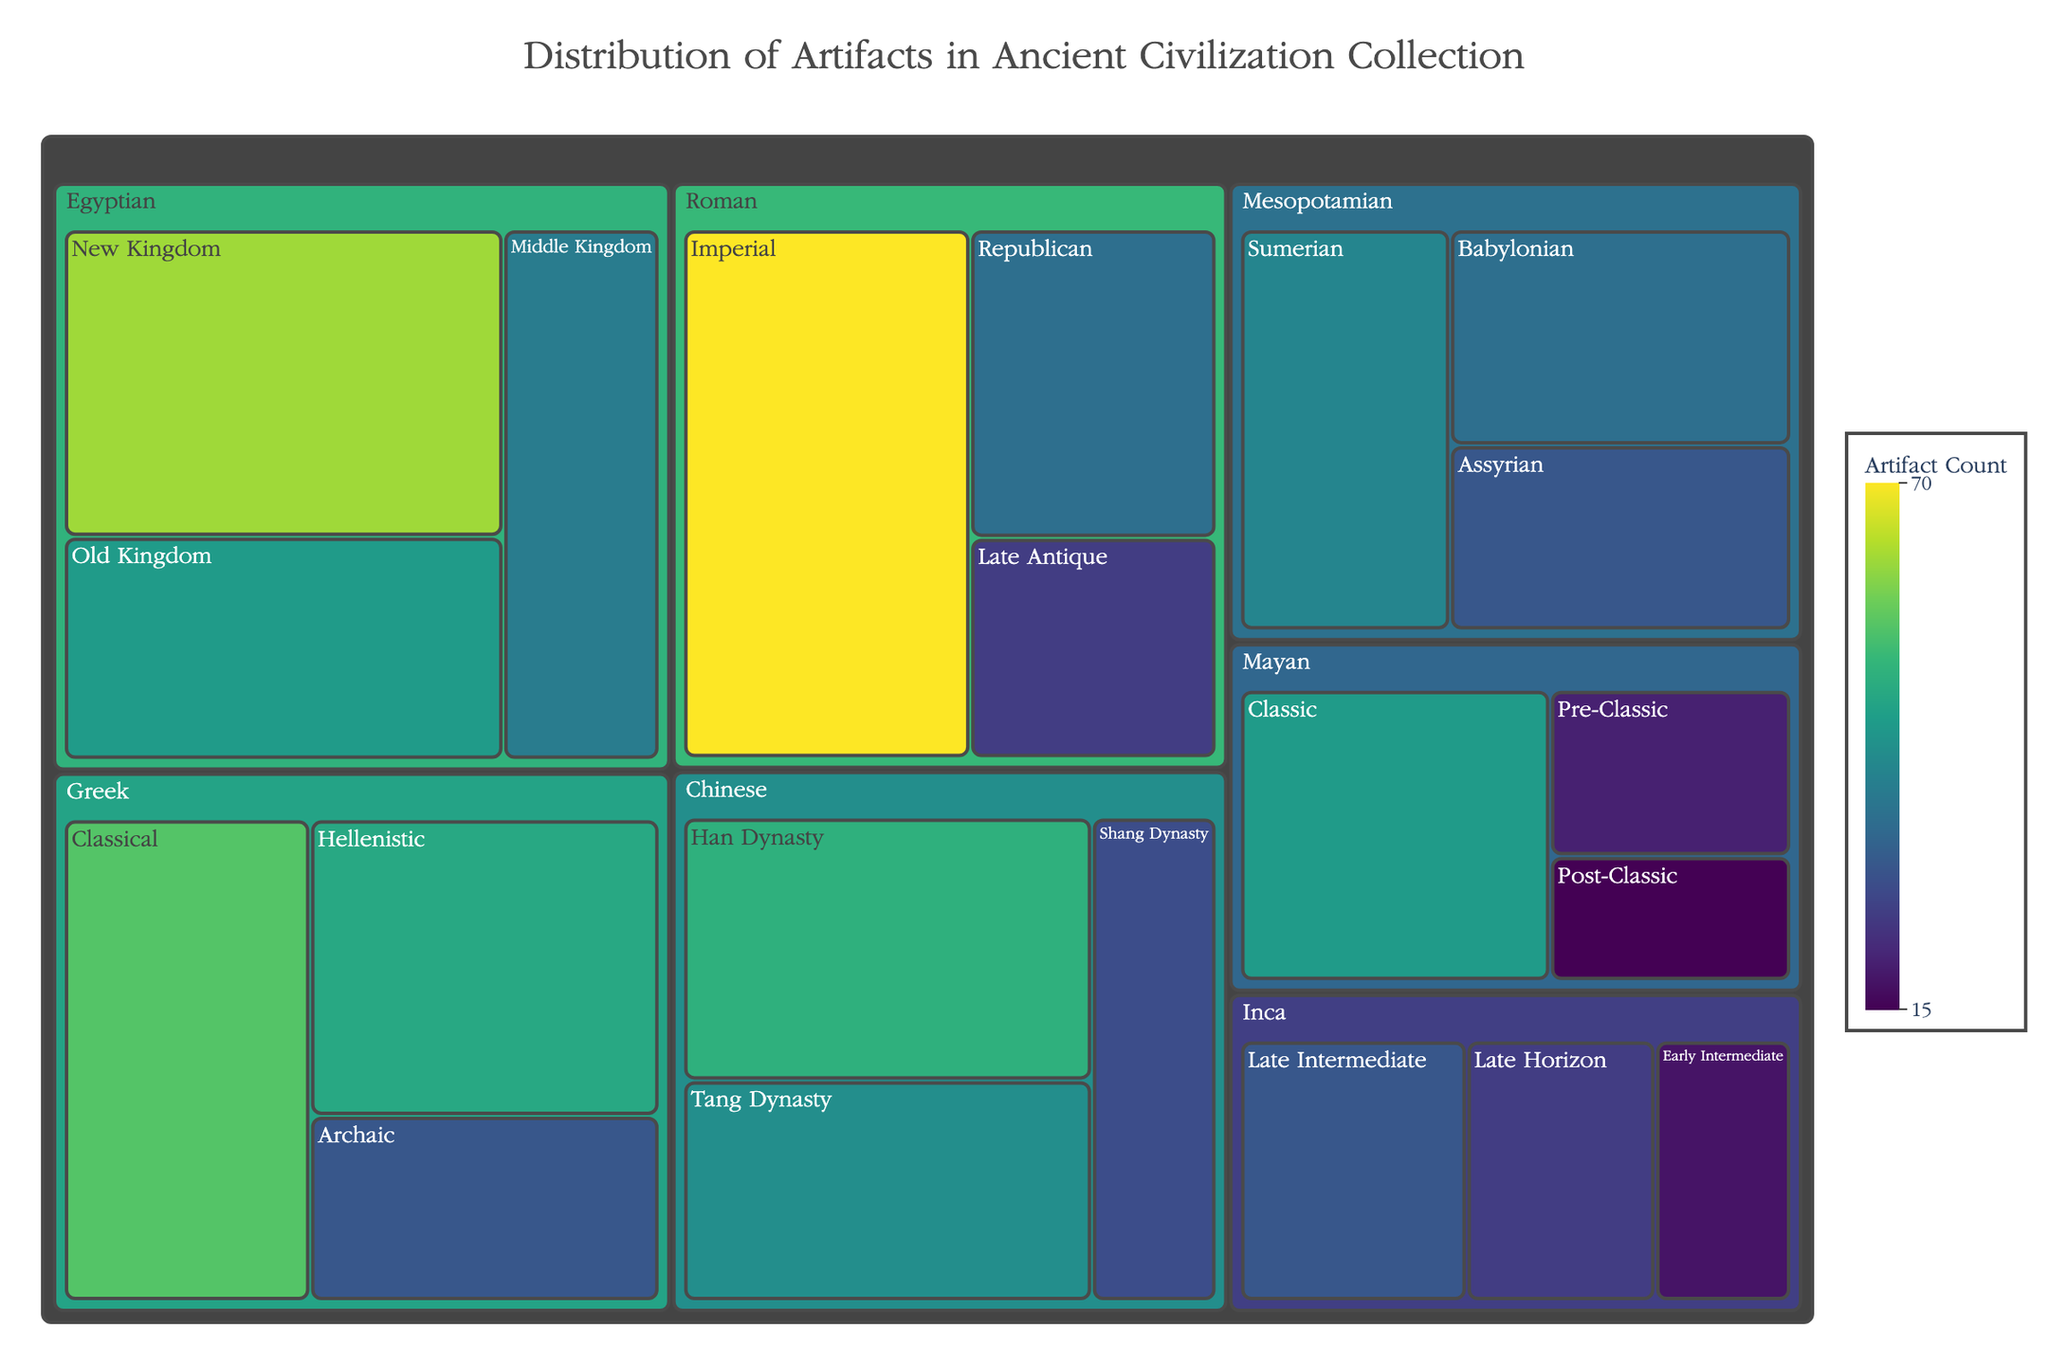Which culture has the highest number of artifacts in the collection? Locate the largest area in the treemap, which corresponds to the culture with the highest number of artifacts. The Roman culture (Imperial period) has the highest count.
Answer: Roman Which period within the Egyptian culture has the most artifacts? Within the Egyptian section of the treemap, identify the sub-area representing the period with the highest count. The New Kingdom has the highest number of artifacts.
Answer: New Kingdom What is the difference in the number of artifacts between the Greek Archaic period and the Greek Hellenistic period? Find the areas representing the Greek Archaic and Hellenistic periods in the treemap and subtract the count of the Archaic period (30) from the count of the Hellenistic period (48). The difference is 48 - 30 = 18.
Answer: 18 Which cultures have at least one period with more than 50 artifacts? Identify the areas where the artifact counts exceed 50, and then determine the corresponding cultures. The Roman, Egyptian, Greek, and Chinese cultures each have periods exceeding 50 artifacts.
Answer: Roman, Egyptian, Greek, Chinese How does the number of artifacts in the Mesopotamian Assyrian period compare to the number in the Chinese Shang Dynasty period? Locate the areas for the Mesopotamian Assyrian (30) and Chinese Shang Dynasty (28) periods in the treemap, and compare their counts. The Assyrian period has more artifacts.
Answer: More in Assyrian Sum the total number of artifacts for all periods of the Mayan culture. In the treemap, find the areas representing each period within the Mayan culture and add their counts: Pre-Classic (20) + Classic (45) + Post-Classic (15). The total is 20 + 45 + 15 = 80.
Answer: 80 What is the distribution pattern of artifacts across different periods in the Inca culture? Examine the areas within the Inca section of the treemap to observe how the artifacts are distributed among the Early Intermediate (18), Late Intermediate (30), and Late Horizon (25) periods. The counts are relatively close, with the Late Intermediate period having the most.
Answer: Late Intermediate highest, others close Which period across all cultures has the lowest number of artifacts? Look for the smallest area in the entire treemap, which represents the period with the lowest count. The Mayan Post-Classic period has the lowest number with 15 artifacts.
Answer: Mayan Post-Classic What is the average number of artifacts across the periods within the Greek culture? In the treemap, find the artifact counts for all Greek periods and calculate the average: (Archaic (30) + Classical (55) + Hellenistic (48)) / 3. The average is (30 + 55 + 48) / 3 = 44.33.
Answer: 44.33 Compare the sum of artifacts in the Classical period of the Greek culture and the Han Dynasty period of the Chinese culture. Which has more? Determine the artifact counts for Greek Classical (55) and the Chinese Han Dynasty (50) and compare their sums. The Greek Classical period has more artifacts.
Answer: Greek Classical period 